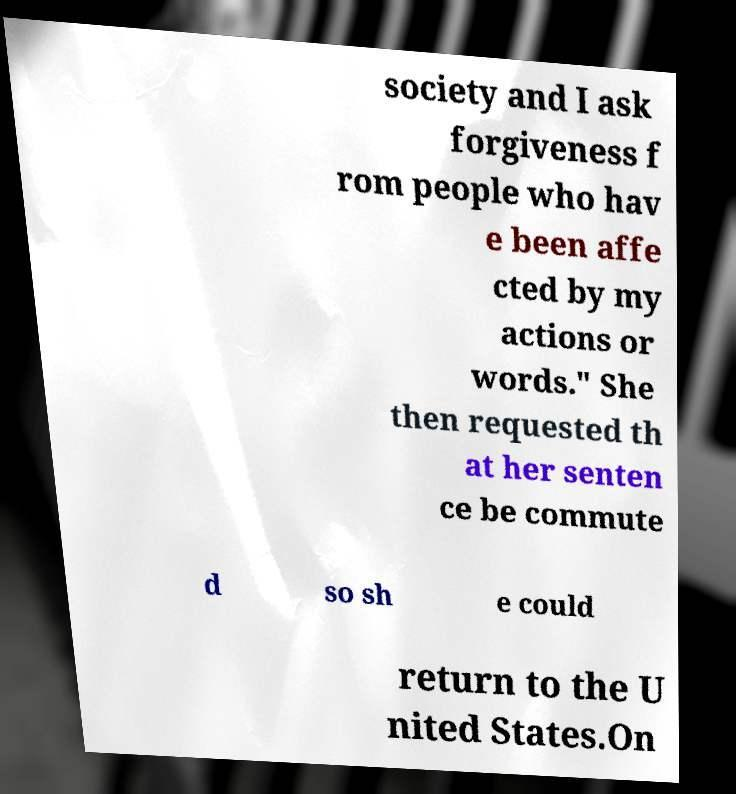Could you extract and type out the text from this image? society and I ask forgiveness f rom people who hav e been affe cted by my actions or words." She then requested th at her senten ce be commute d so sh e could return to the U nited States.On 